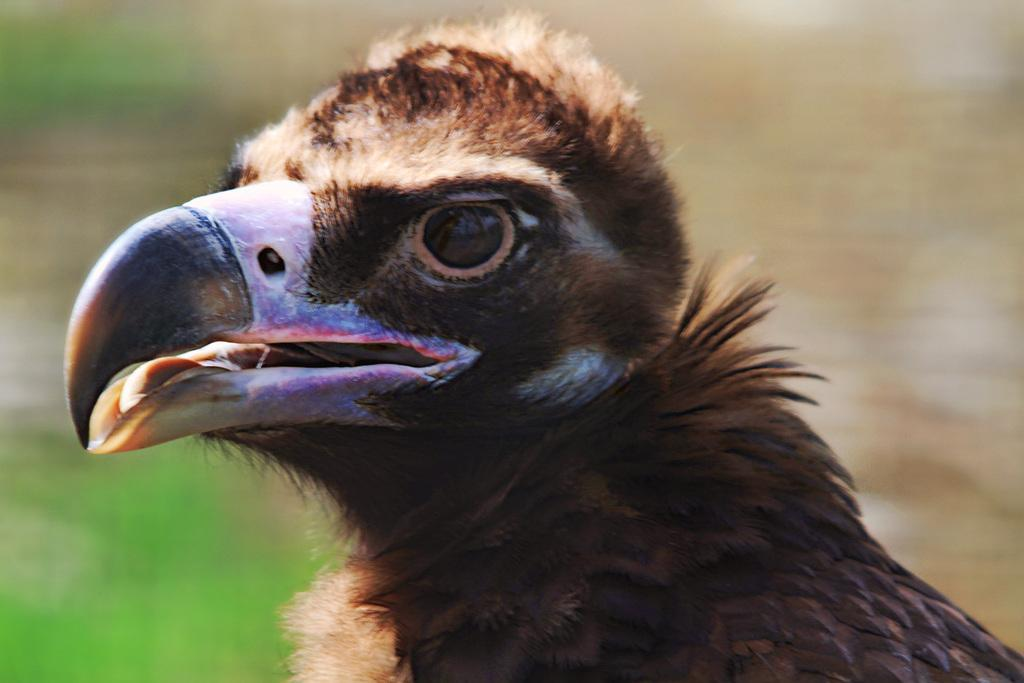What type of animal can be seen in the image? There is a bird in the image. Can you describe the background of the image? The background of the image is blurred. What type of brass instrument is the bird playing in the image? There is no brass instrument present in the image, as it features a bird and a blurred background. 